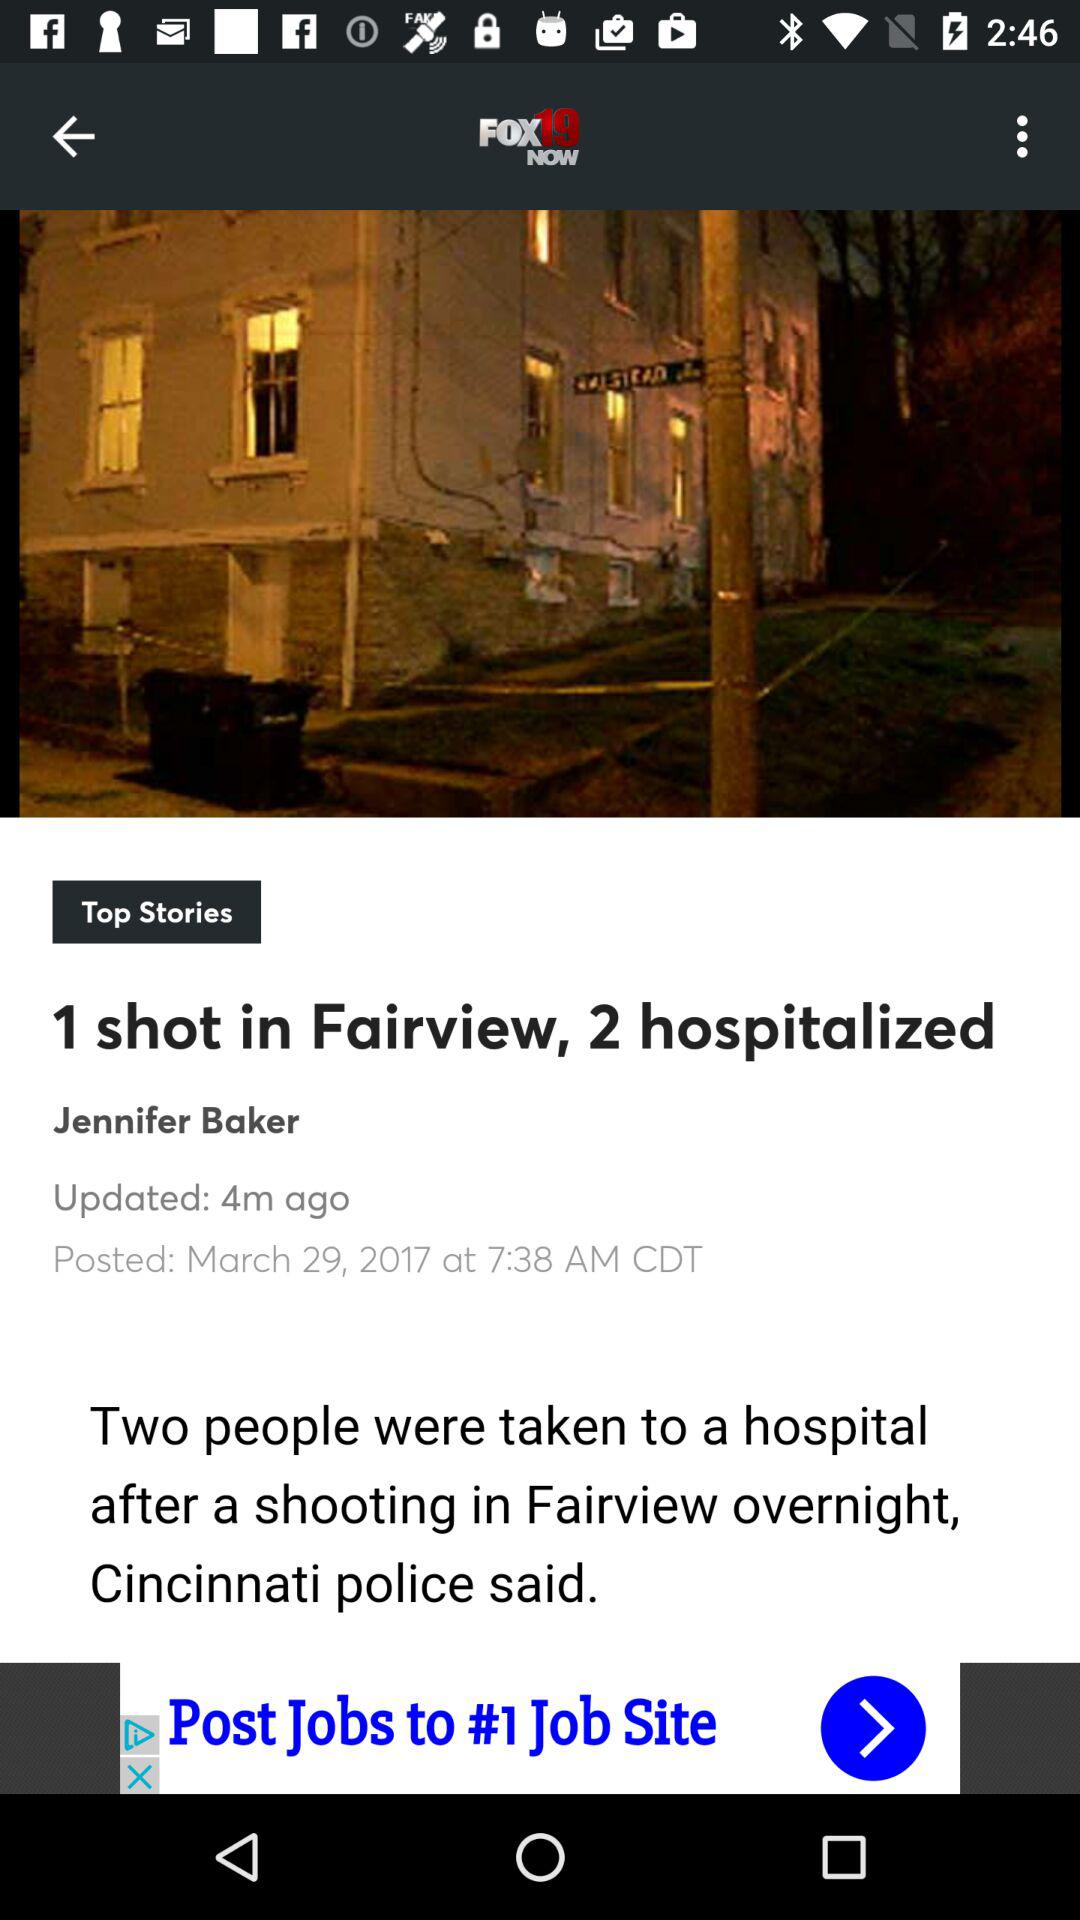What is the author name? The author name is Jennifer Baker. 